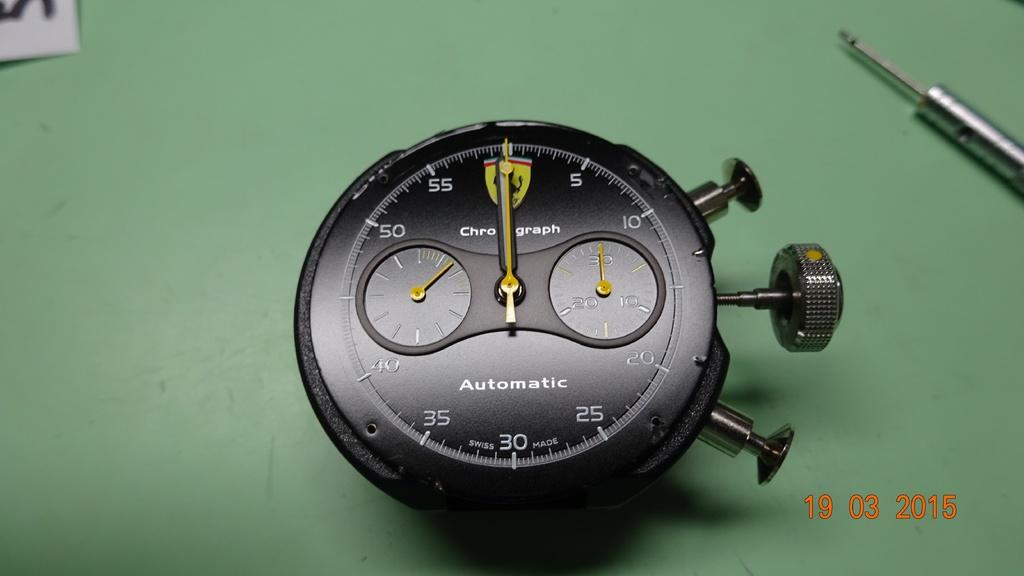<image>
Provide a brief description of the given image. A black stopwatch says that it is both automatic and Swiss made. 